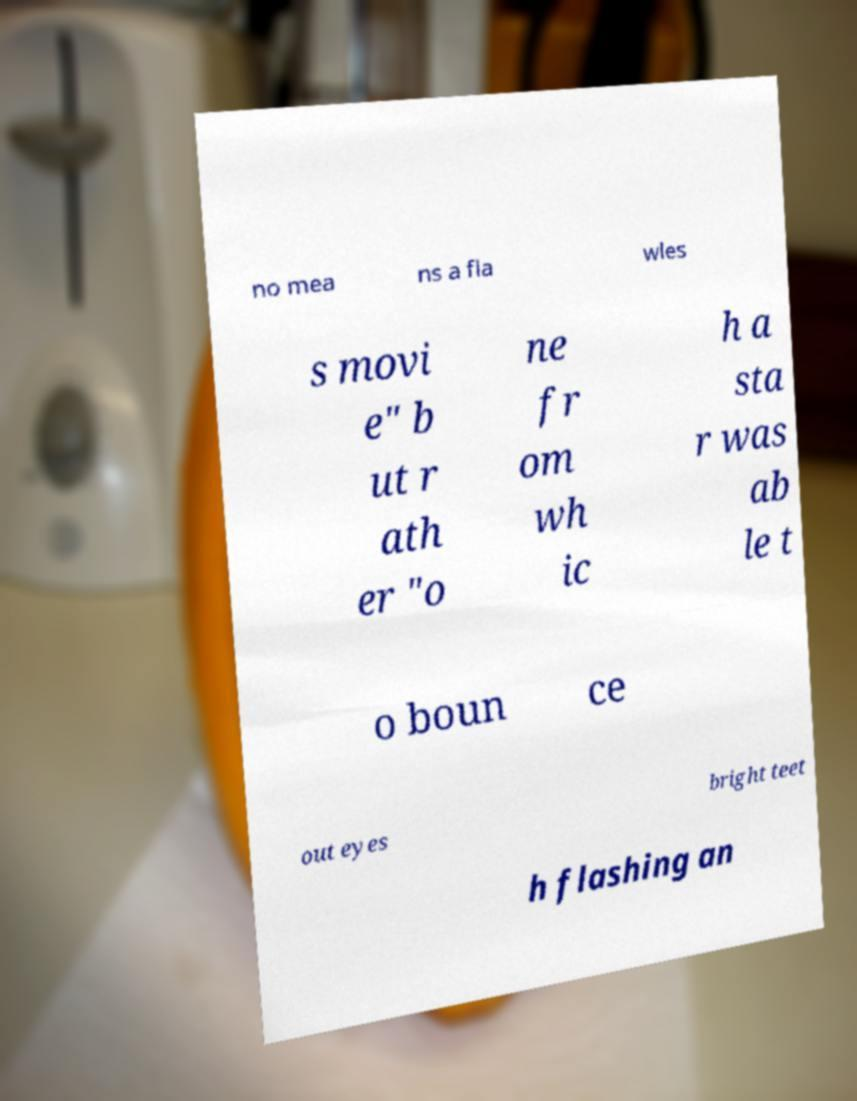Please identify and transcribe the text found in this image. no mea ns a fla wles s movi e" b ut r ath er "o ne fr om wh ic h a sta r was ab le t o boun ce out eyes bright teet h flashing an 